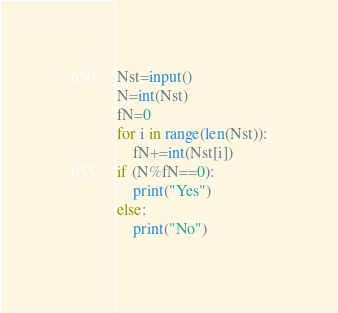Convert code to text. <code><loc_0><loc_0><loc_500><loc_500><_Python_>Nst=input()
N=int(Nst)
fN=0
for i in range(len(Nst)):
    fN+=int(Nst[i])
if (N%fN==0):
    print("Yes")
else:
    print("No")</code> 